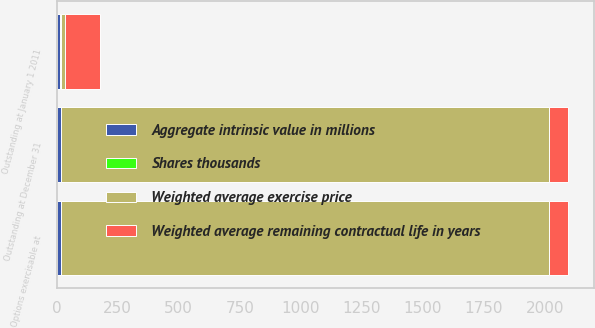Convert chart. <chart><loc_0><loc_0><loc_500><loc_500><stacked_bar_chart><ecel><fcel>Outstanding at January 1 2011<fcel>Outstanding at December 31<fcel>Options exercisable at<nl><fcel>Weighted average exercise price<fcel>15.82<fcel>1997<fcel>1997<nl><fcel>Aggregate intrinsic value in millions<fcel>14.32<fcel>15.82<fcel>15.82<nl><fcel>Shares thousands<fcel>4.9<fcel>2.6<fcel>2.6<nl><fcel>Weighted average remaining contractual life in years<fcel>142.2<fcel>80<fcel>80<nl></chart> 